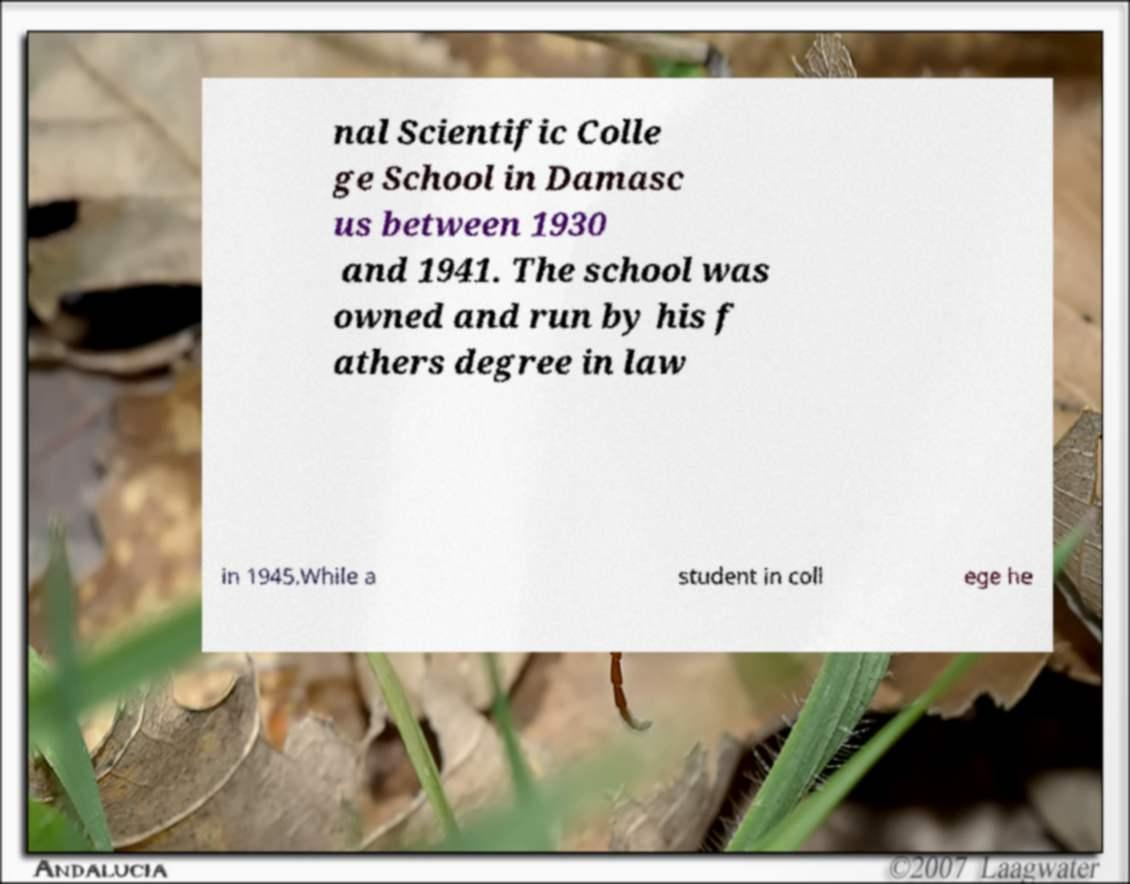Please read and relay the text visible in this image. What does it say? nal Scientific Colle ge School in Damasc us between 1930 and 1941. The school was owned and run by his f athers degree in law in 1945.While a student in coll ege he 